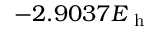<formula> <loc_0><loc_0><loc_500><loc_500>- 2 . 9 0 3 7 E _ { h }</formula> 